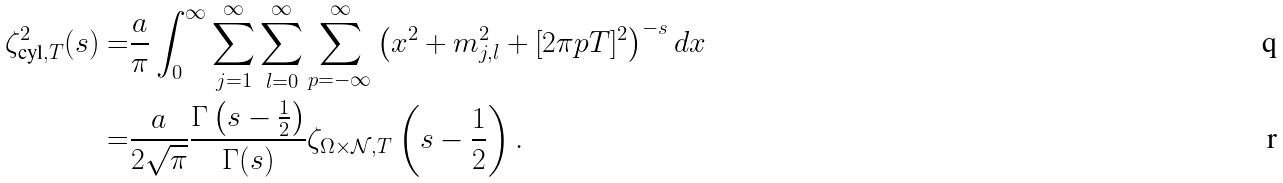<formula> <loc_0><loc_0><loc_500><loc_500>\zeta _ { \text {cyl} , T } ^ { 2 } ( s ) = & \frac { a } { \pi } \int _ { 0 } ^ { \infty } \sum _ { j = 1 } ^ { \infty } \sum _ { l = 0 } ^ { \infty } \sum _ { p = - \infty } ^ { \infty } \left ( x ^ { 2 } + m _ { j , l } ^ { 2 } + [ 2 \pi p T ] ^ { 2 } \right ) ^ { - s } d x \\ = & \frac { a } { 2 \sqrt { \pi } } \frac { \Gamma \left ( s - \frac { 1 } { 2 } \right ) } { \Gamma ( s ) } \zeta _ { \Omega \times \mathcal { N } , T } \left ( s - \frac { 1 } { 2 } \right ) .</formula> 